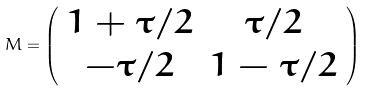<formula> <loc_0><loc_0><loc_500><loc_500>M = \left ( \begin{array} { c c } 1 + \tau / 2 & \tau / 2 \\ - \tau / 2 & 1 - \tau / 2 \end{array} \right )</formula> 